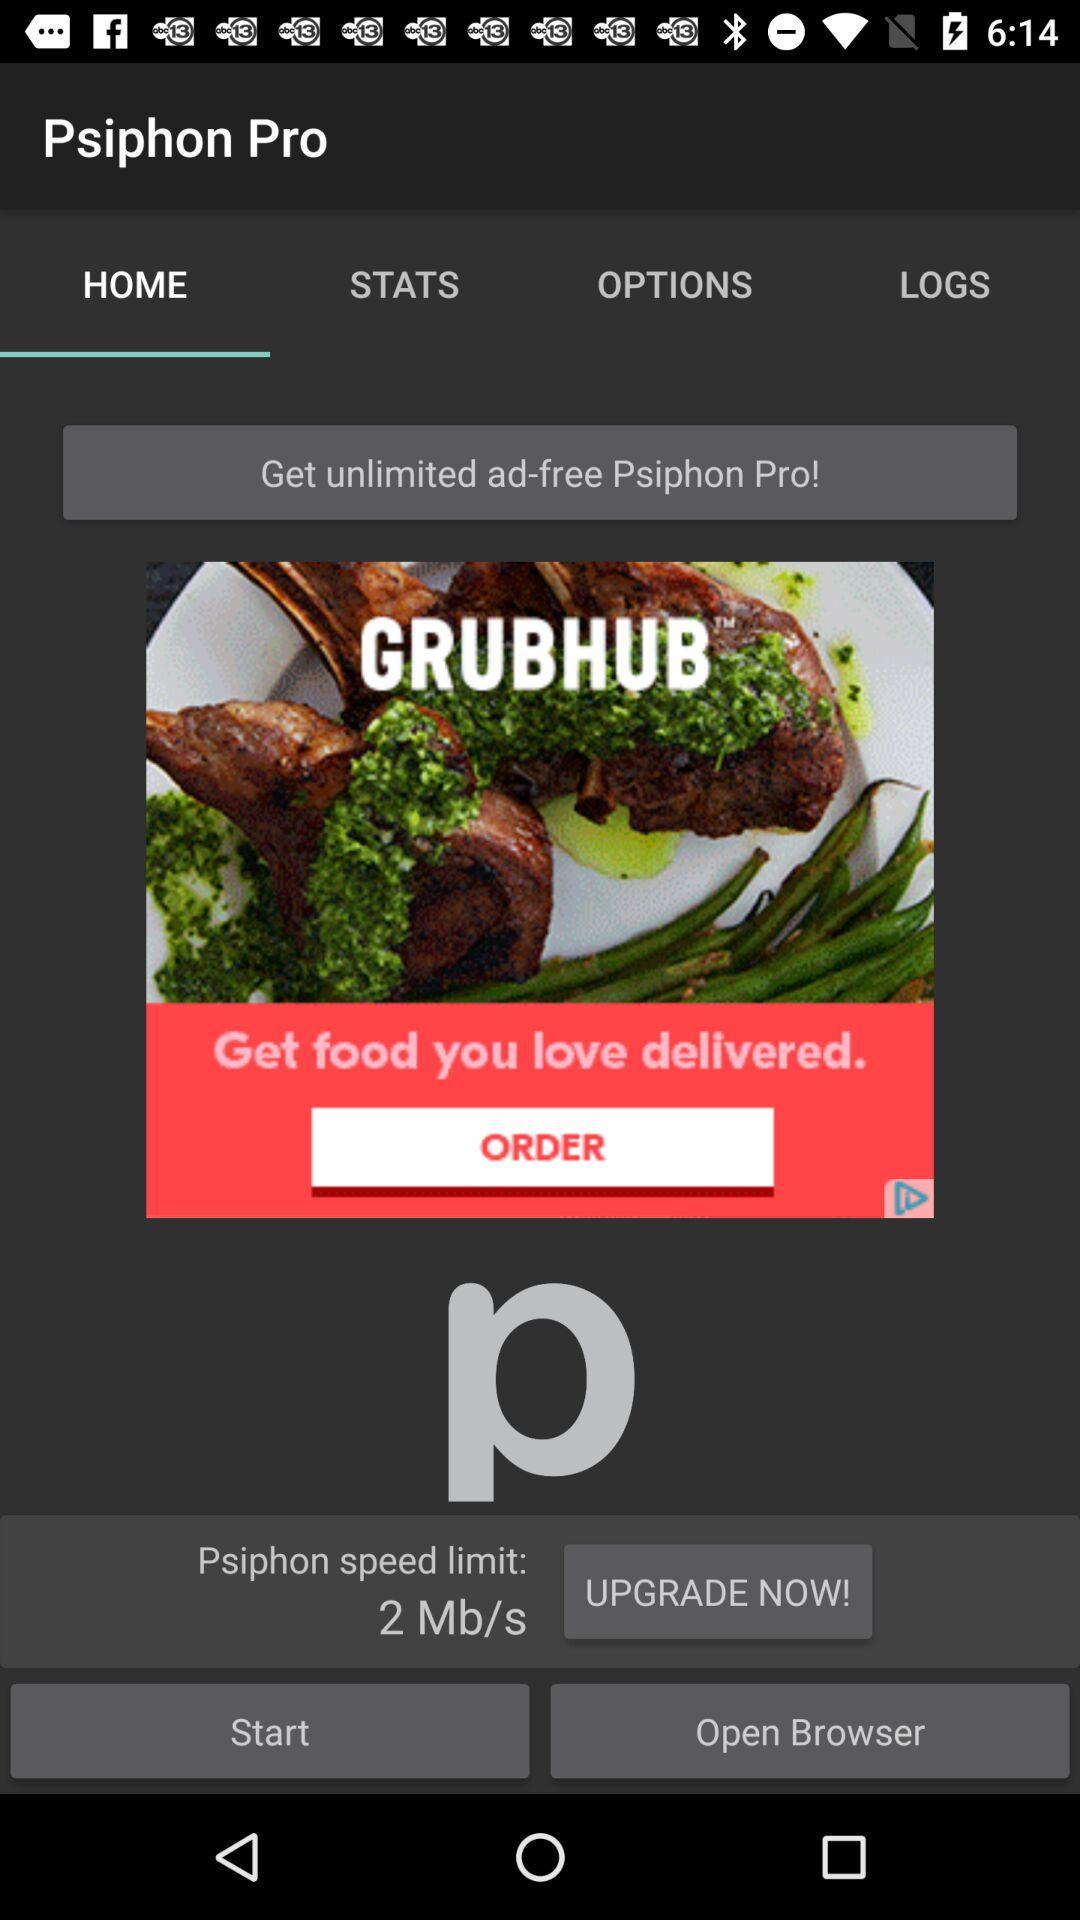What is the Psiphon speed limit? The Psiphon speed limit is 2 Mb/s. 